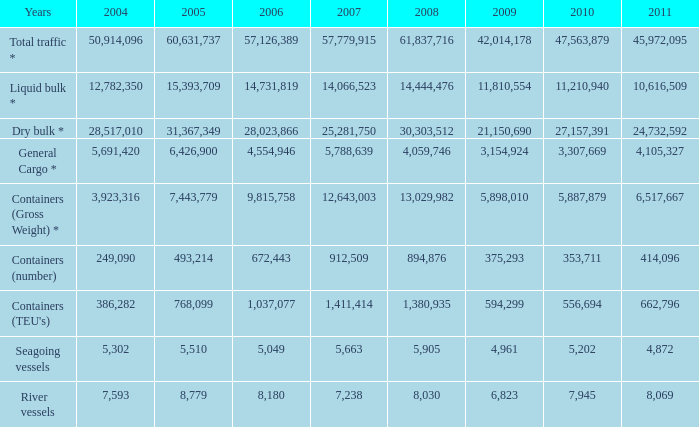What is the highest value in 2011 with less than 5,049 in 2006 and less than 1,380,935 in 2008? None. 